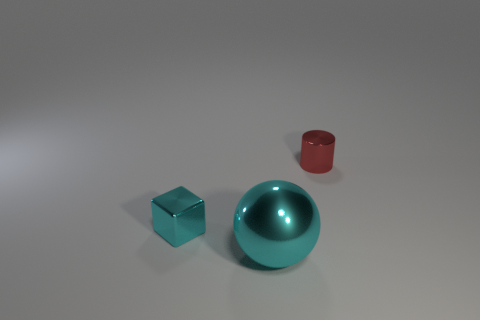Add 1 tiny cyan cubes. How many objects exist? 4 Subtract all blocks. How many objects are left? 2 Add 2 big red metal cylinders. How many big red metal cylinders exist? 2 Subtract 0 brown cylinders. How many objects are left? 3 Subtract all red shiny cylinders. Subtract all large cyan things. How many objects are left? 1 Add 2 cylinders. How many cylinders are left? 3 